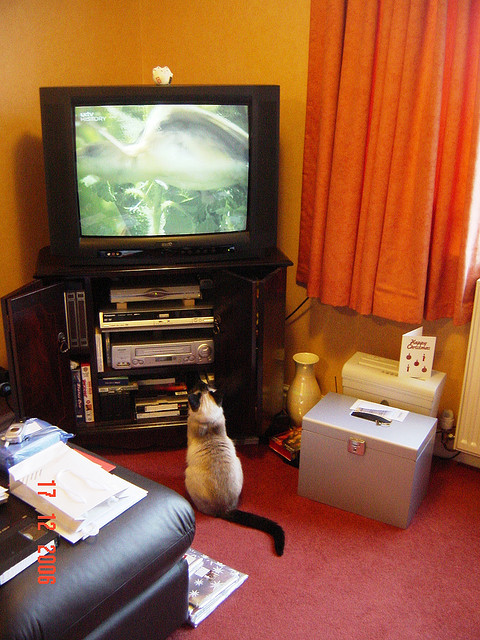Extract all visible text content from this image. 17 12 2006 